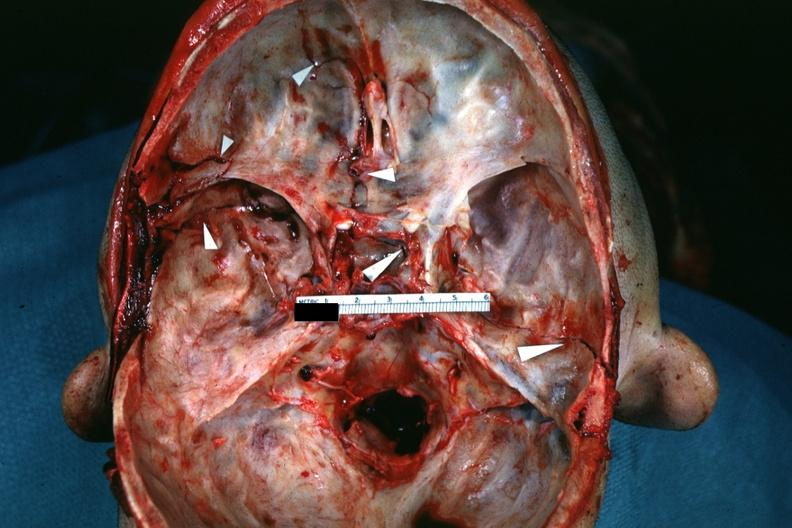does this image show fractures brain which is slide and close-up view of these fractures is slide?
Answer the question using a single word or phrase. Yes 